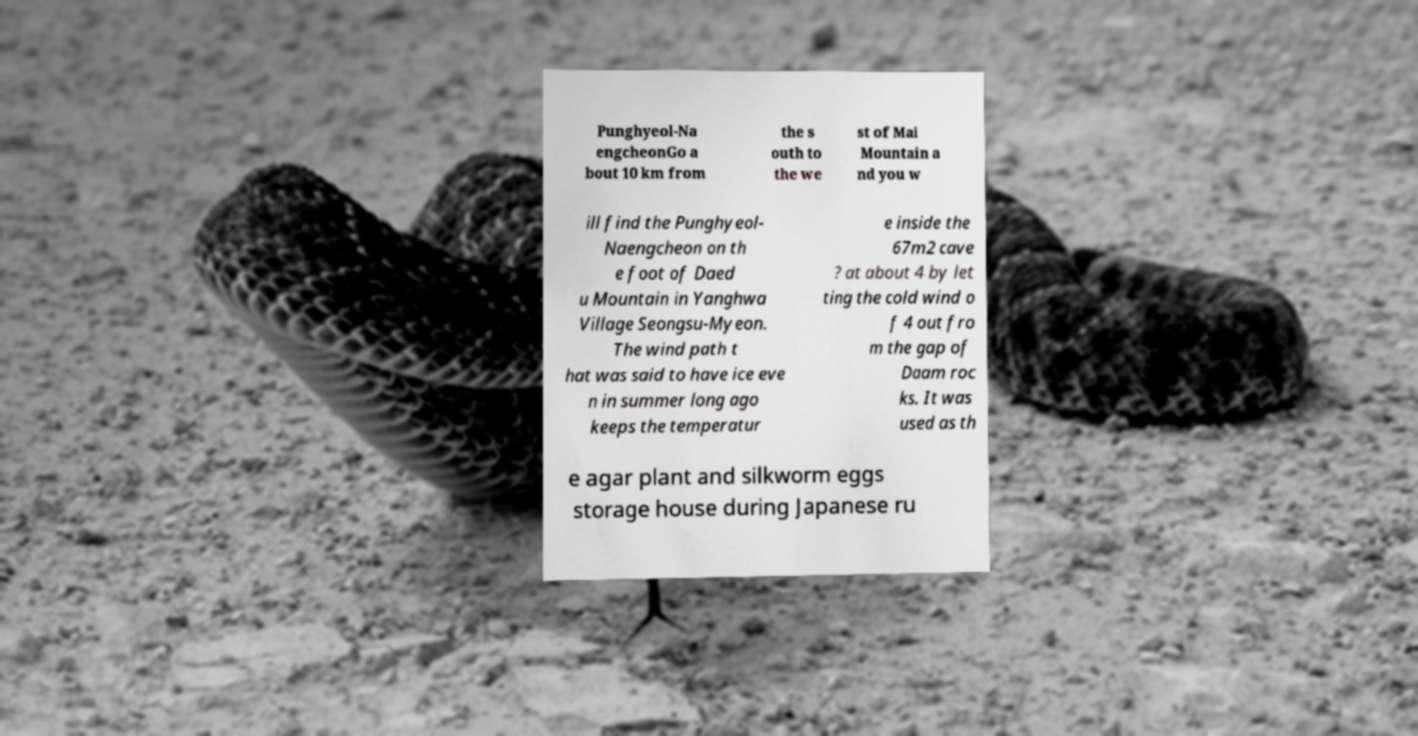Could you assist in decoding the text presented in this image and type it out clearly? Punghyeol-Na engcheonGo a bout 10 km from the s outh to the we st of Mai Mountain a nd you w ill find the Punghyeol- Naengcheon on th e foot of Daed u Mountain in Yanghwa Village Seongsu-Myeon. The wind path t hat was said to have ice eve n in summer long ago keeps the temperatur e inside the 67m2 cave ? at about 4 by let ting the cold wind o f 4 out fro m the gap of Daam roc ks. It was used as th e agar plant and silkworm eggs storage house during Japanese ru 